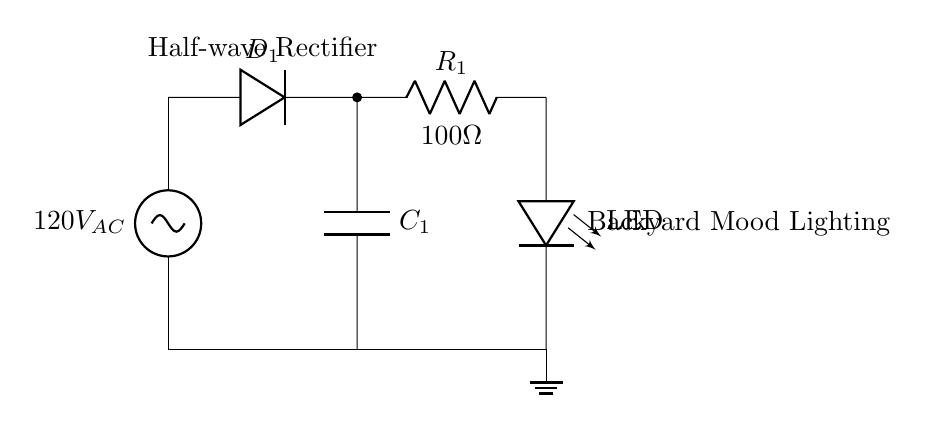What is the type of rectifier used in this circuit? This circuit is labeled as a "Half-wave Rectifier," indicating that it only allows one half of the AC wave to pass through while blocking the other half.
Answer: Half-wave What is the resistance value of the resistor in the circuit? The resistor in the circuit is labeled with a notation that specifies its resistance value as "100 ohms", which is mentioned next to the component symbol.
Answer: 100 ohms What component is used to convert AC to DC in this circuit? The component responsible for converting AC to DC is the diode, indicated by the symbol "D1" in the circuit. It allows current to flow in one direction only.
Answer: Diode What is the purpose of the capacitor in this circuit? The capacitor's role in this circuit is to smooth the output voltage by filtering the rectified waveform, which reduces ripple, ensuring a more stable DC voltage for the LEDs.
Answer: Smoothing Where does the DC output from the rectifier feed into? The output of the circuit, after the smoothing and rectification process, feeds into the LED, which is used to power the backyard mood lighting. The LED is labeled in the diagram.
Answer: LED What is the voltage of the AC source in the circuit? The circuit diagram shows that the AC voltage source is "120V AC," as labeled next to the voltage source symbol at the top of the diagram.
Answer: 120V AC What happens to the current during the non-conducting half of the AC cycle? During the non-conducting half of the AC cycle, the diode prevents current from flowing, resulting in no output voltage reaching the LED in that half-cycle.
Answer: No current 